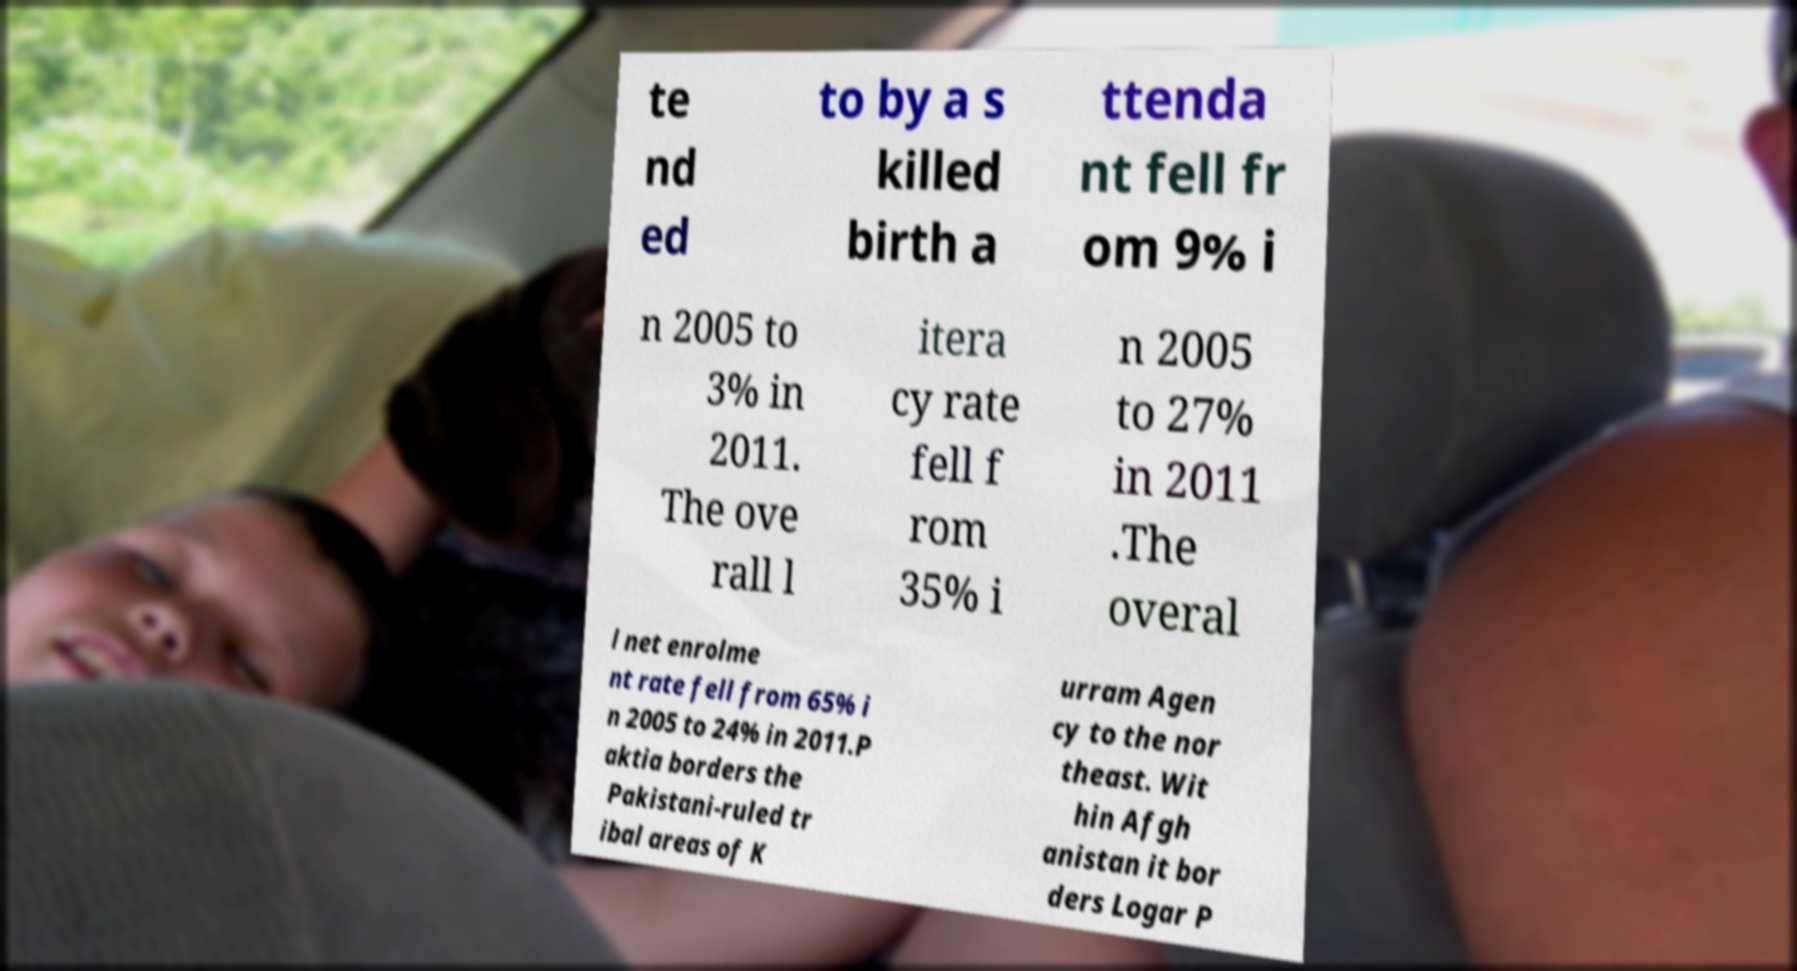Could you extract and type out the text from this image? te nd ed to by a s killed birth a ttenda nt fell fr om 9% i n 2005 to 3% in 2011. The ove rall l itera cy rate fell f rom 35% i n 2005 to 27% in 2011 .The overal l net enrolme nt rate fell from 65% i n 2005 to 24% in 2011.P aktia borders the Pakistani-ruled tr ibal areas of K urram Agen cy to the nor theast. Wit hin Afgh anistan it bor ders Logar P 